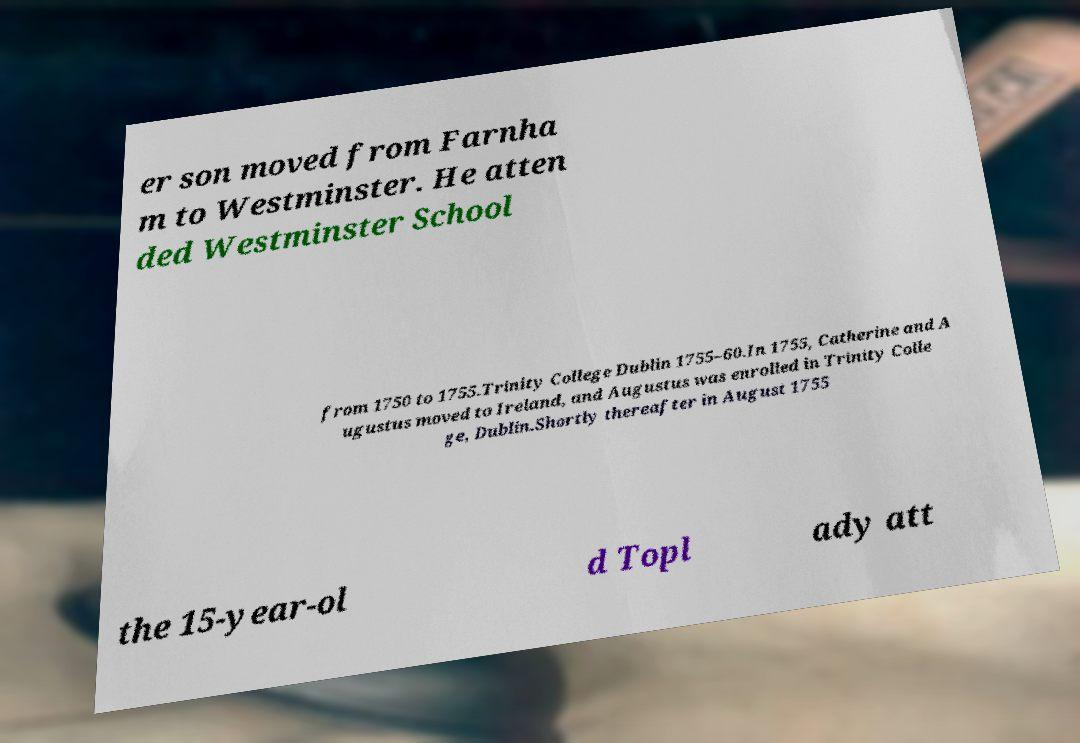There's text embedded in this image that I need extracted. Can you transcribe it verbatim? er son moved from Farnha m to Westminster. He atten ded Westminster School from 1750 to 1755.Trinity College Dublin 1755–60.In 1755, Catherine and A ugustus moved to Ireland, and Augustus was enrolled in Trinity Colle ge, Dublin.Shortly thereafter in August 1755 the 15-year-ol d Topl ady att 